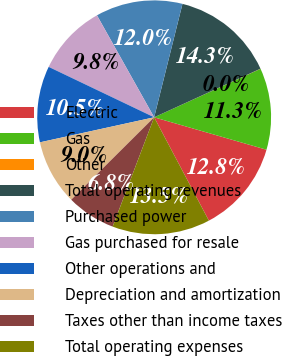Convert chart. <chart><loc_0><loc_0><loc_500><loc_500><pie_chart><fcel>Electric<fcel>Gas<fcel>Other<fcel>Total operating revenues<fcel>Purchased power<fcel>Gas purchased for resale<fcel>Other operations and<fcel>Depreciation and amortization<fcel>Taxes other than income taxes<fcel>Total operating expenses<nl><fcel>12.78%<fcel>11.28%<fcel>0.02%<fcel>14.28%<fcel>12.03%<fcel>9.77%<fcel>10.53%<fcel>9.02%<fcel>6.77%<fcel>13.53%<nl></chart> 